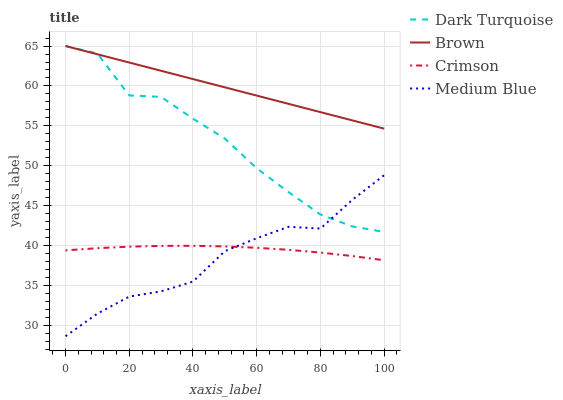Does Medium Blue have the minimum area under the curve?
Answer yes or no. Yes. Does Brown have the maximum area under the curve?
Answer yes or no. Yes. Does Dark Turquoise have the minimum area under the curve?
Answer yes or no. No. Does Dark Turquoise have the maximum area under the curve?
Answer yes or no. No. Is Brown the smoothest?
Answer yes or no. Yes. Is Dark Turquoise the roughest?
Answer yes or no. Yes. Is Medium Blue the smoothest?
Answer yes or no. No. Is Medium Blue the roughest?
Answer yes or no. No. Does Dark Turquoise have the lowest value?
Answer yes or no. No. Does Medium Blue have the highest value?
Answer yes or no. No. Is Crimson less than Dark Turquoise?
Answer yes or no. Yes. Is Brown greater than Medium Blue?
Answer yes or no. Yes. Does Crimson intersect Dark Turquoise?
Answer yes or no. No. 